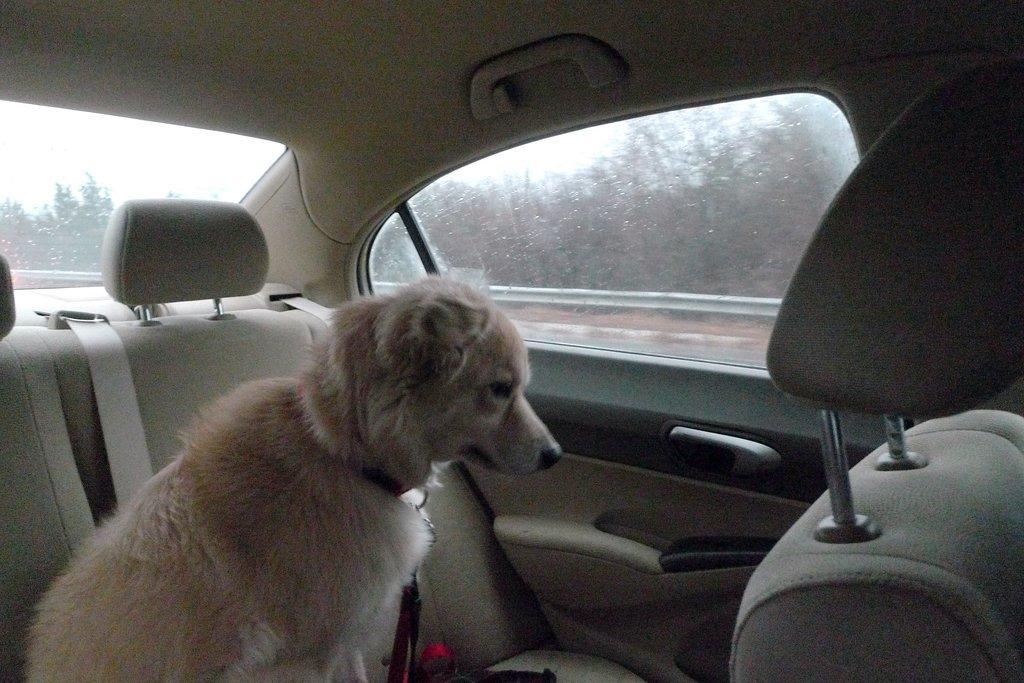In one or two sentences, can you explain what this image depicts? In this image I see a dog which is in a vehicle. In the background I see trees. 